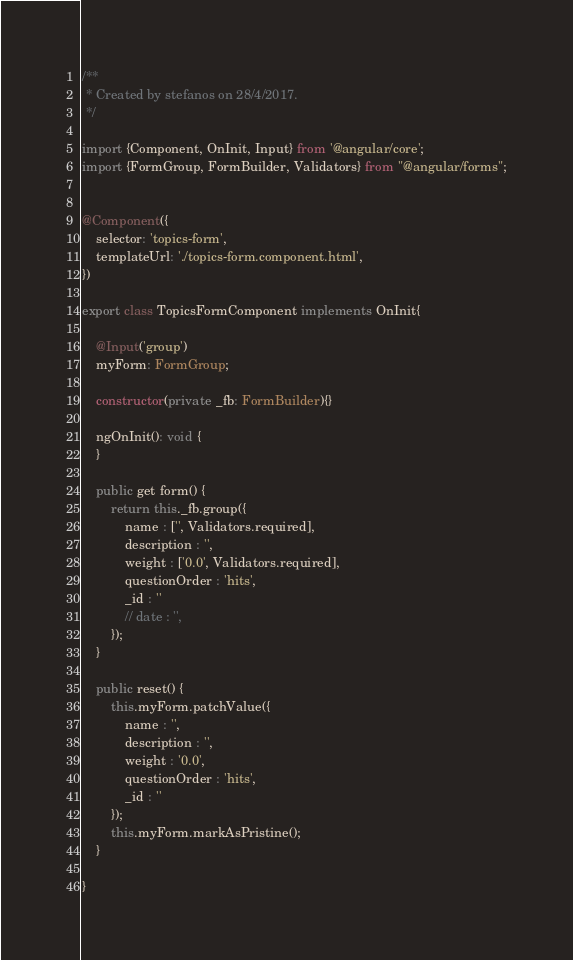<code> <loc_0><loc_0><loc_500><loc_500><_TypeScript_>/**
 * Created by stefanos on 28/4/2017.
 */

import {Component, OnInit, Input} from '@angular/core';
import {FormGroup, FormBuilder, Validators} from "@angular/forms";


@Component({
    selector: 'topics-form',
    templateUrl: './topics-form.component.html',
})

export class TopicsFormComponent implements OnInit{

    @Input('group')
    myForm: FormGroup;

    constructor(private _fb: FormBuilder){}

    ngOnInit(): void {
    }

    public get form() {
        return this._fb.group({
            name : ['', Validators.required],
            description : '',
            weight : ['0.0', Validators.required],
            questionOrder : 'hits',
            _id : ''
            // date : '',
        });
    }

    public reset() {
        this.myForm.patchValue({
            name : '',
            description : '',
            weight : '0.0',
            questionOrder : 'hits',
            _id : ''
        });
        this.myForm.markAsPristine();
    }

}</code> 